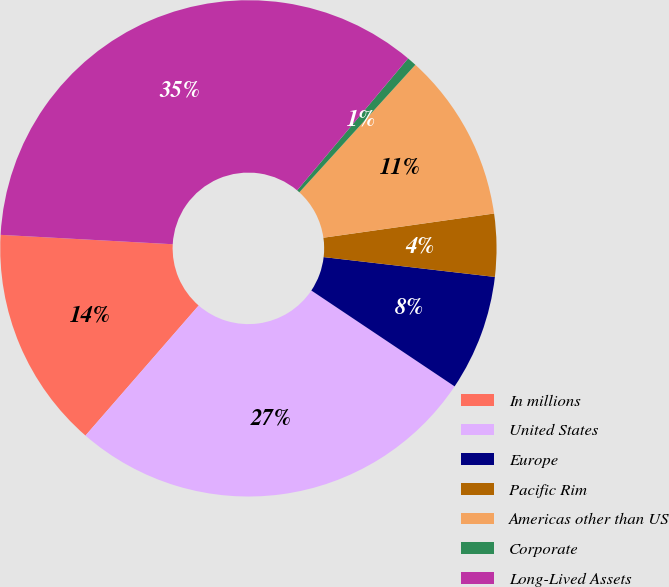Convert chart to OTSL. <chart><loc_0><loc_0><loc_500><loc_500><pie_chart><fcel>In millions<fcel>United States<fcel>Europe<fcel>Pacific Rim<fcel>Americas other than US<fcel>Corporate<fcel>Long-Lived Assets<nl><fcel>14.47%<fcel>27.01%<fcel>7.55%<fcel>4.08%<fcel>11.01%<fcel>0.62%<fcel>35.26%<nl></chart> 